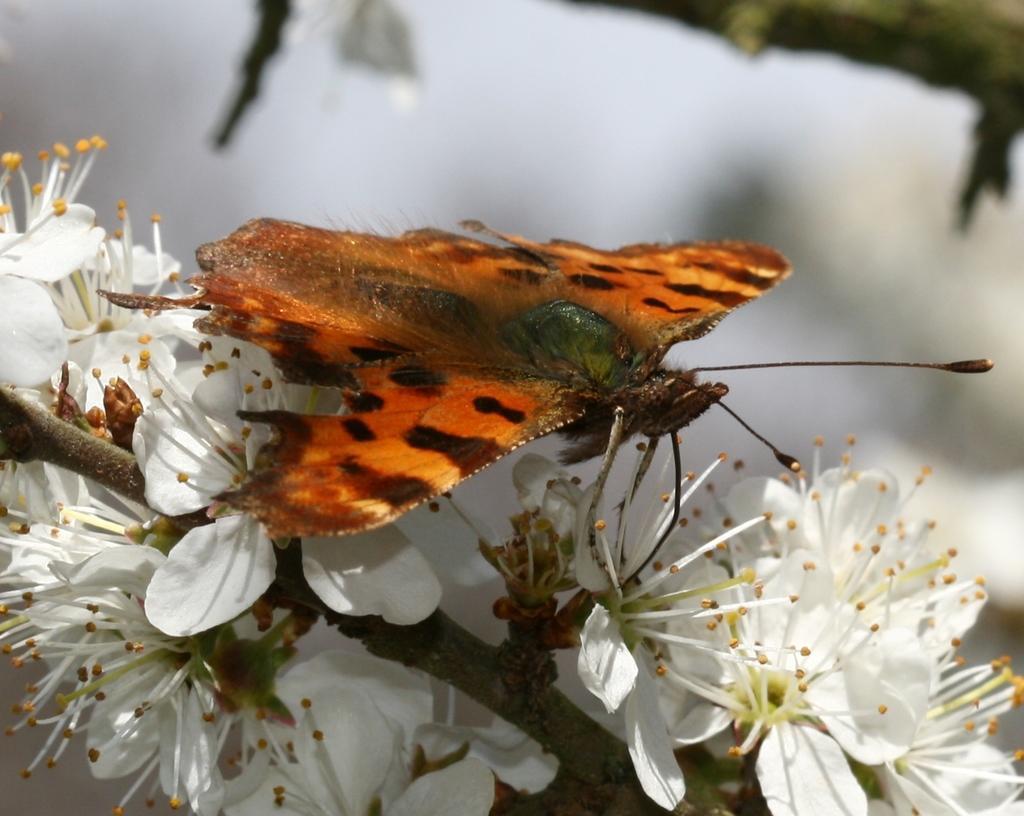Describe this image in one or two sentences. In this picture we can see butterfly, flowers and branch. In the background of the image it is blurry. 